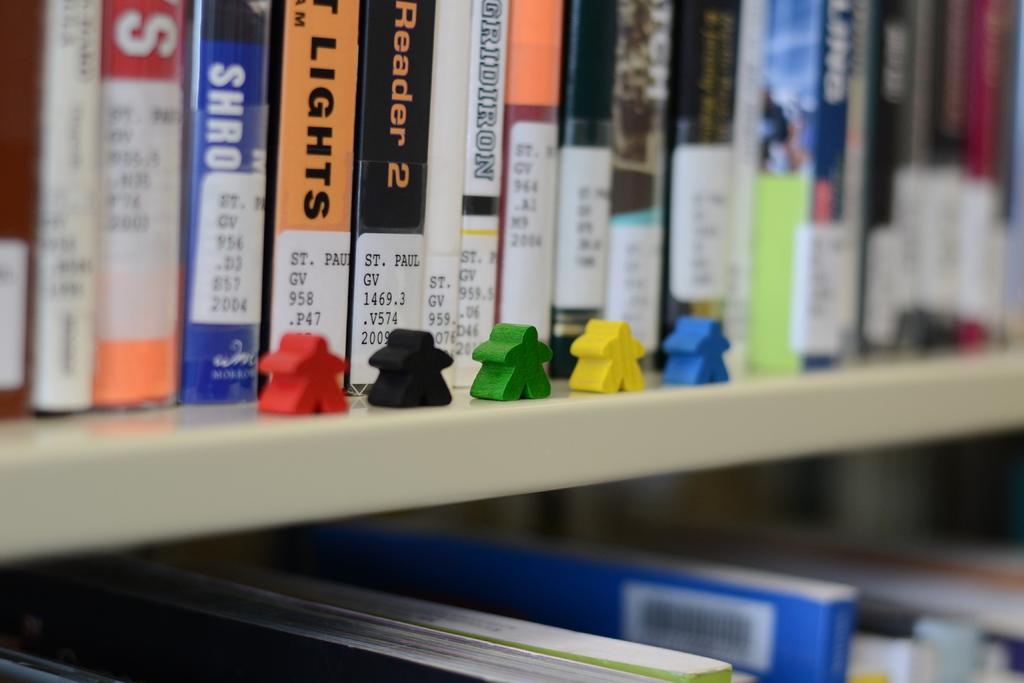What can be seen in the image that is used for storing books? There is a book rack in the image. What type of objects are present in the image that are colorful? There are colorful objects in the image. What type of trees can be seen in the image? There are no trees present in the image. 